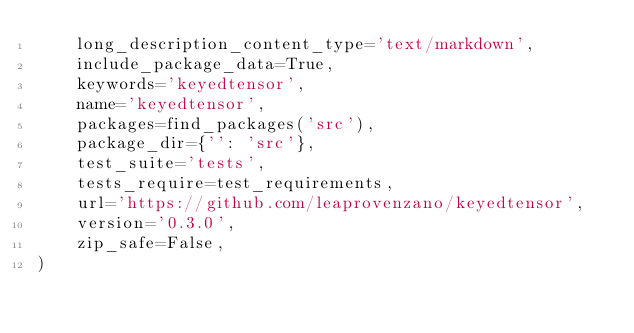<code> <loc_0><loc_0><loc_500><loc_500><_Python_>    long_description_content_type='text/markdown',
    include_package_data=True,
    keywords='keyedtensor',
    name='keyedtensor',
    packages=find_packages('src'),
    package_dir={'': 'src'},
    test_suite='tests',
    tests_require=test_requirements,
    url='https://github.com/leaprovenzano/keyedtensor',
    version='0.3.0',
    zip_safe=False,
)
</code> 